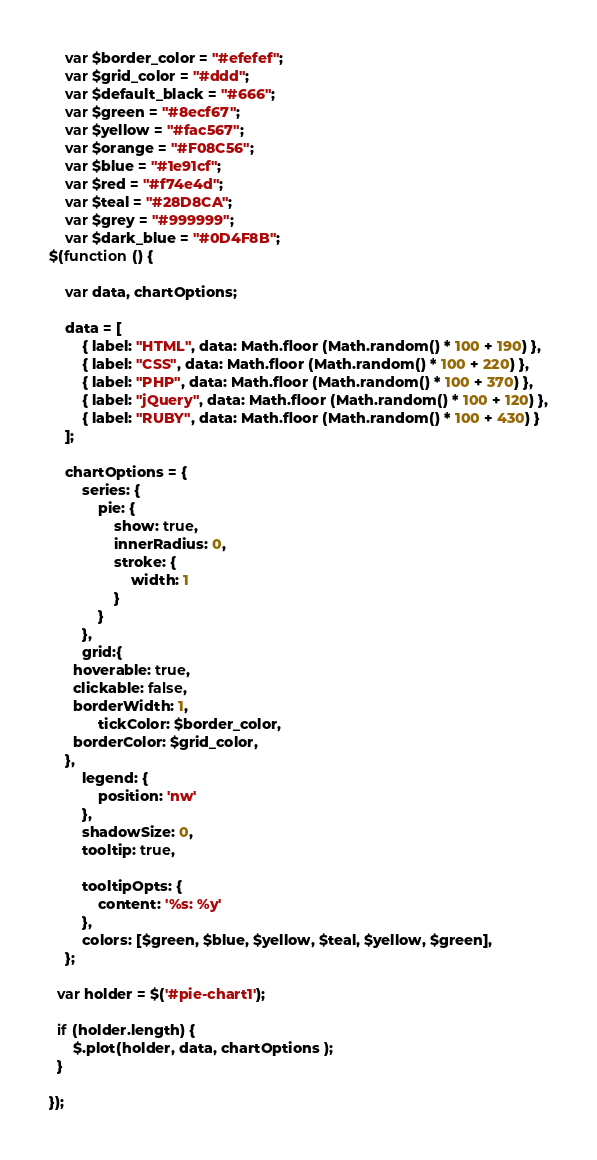Convert code to text. <code><loc_0><loc_0><loc_500><loc_500><_JavaScript_>	var $border_color = "#efefef";
	var $grid_color = "#ddd";
	var $default_black = "#666";
	var $green = "#8ecf67";
	var $yellow = "#fac567";
	var $orange = "#F08C56";
	var $blue = "#1e91cf";
	var $red = "#f74e4d";
	var $teal = "#28D8CA";
	var $grey = "#999999";
	var $dark_blue = "#0D4F8B";
$(function () {

	var data, chartOptions;
	
	data = [
		{ label: "HTML", data: Math.floor (Math.random() * 100 + 190) }, 
		{ label: "CSS", data: Math.floor (Math.random() * 100 + 220) }, 
		{ label: "PHP", data: Math.floor (Math.random() * 100 + 370) }, 
		{ label: "jQuery", data: Math.floor (Math.random() * 100 + 120) },
		{ label: "RUBY", data: Math.floor (Math.random() * 100 + 430) }
	];

	chartOptions = {		
		series: {
			pie: {
				show: true,  
				innerRadius: 0, 
				stroke: {
					width: 1
				}
			}
		},
		grid:{
      hoverable: true,
      clickable: false,
      borderWidth: 1,
			tickColor: $border_color,
      borderColor: $grid_color,
    },
		legend: {
			position: 'nw'
		},
		shadowSize: 0,
		tooltip: true,
		
		tooltipOpts: {
			content: '%s: %y'
		},
		colors: [$green, $blue, $yellow, $teal, $yellow, $green],
	};

  var holder = $('#pie-chart1');

  if (holder.length) {
      $.plot(holder, data, chartOptions );
  }
			
});</code> 